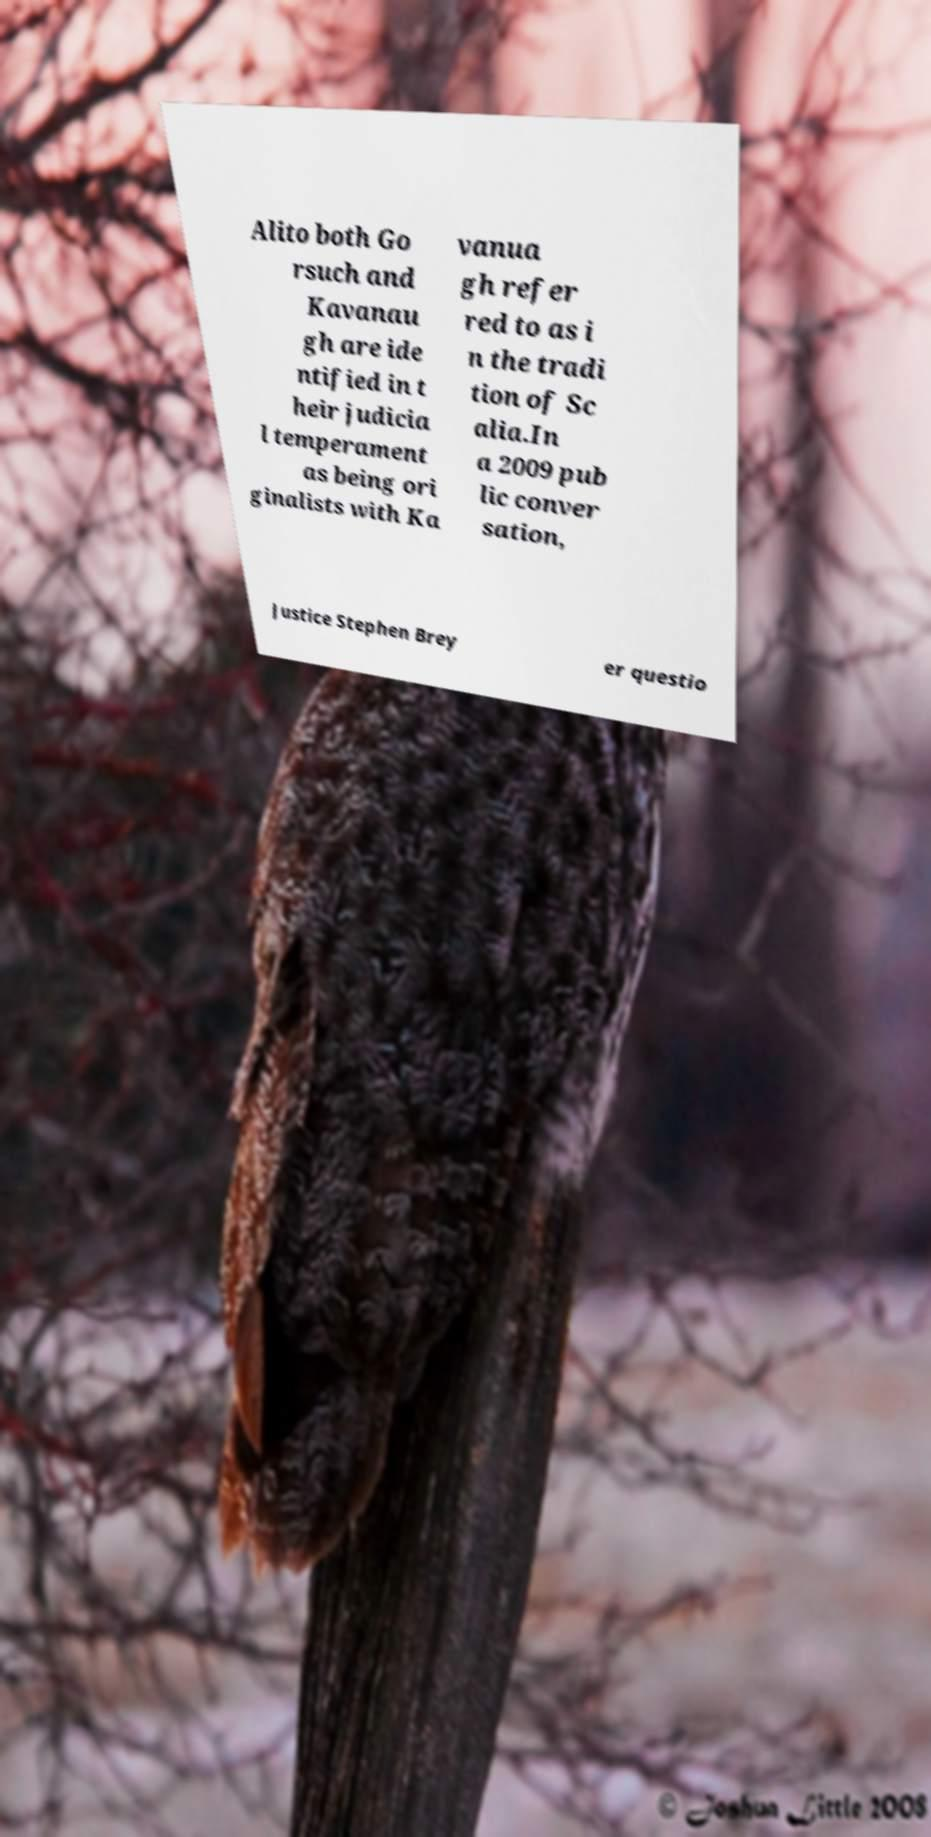Can you accurately transcribe the text from the provided image for me? Alito both Go rsuch and Kavanau gh are ide ntified in t heir judicia l temperament as being ori ginalists with Ka vanua gh refer red to as i n the tradi tion of Sc alia.In a 2009 pub lic conver sation, Justice Stephen Brey er questio 